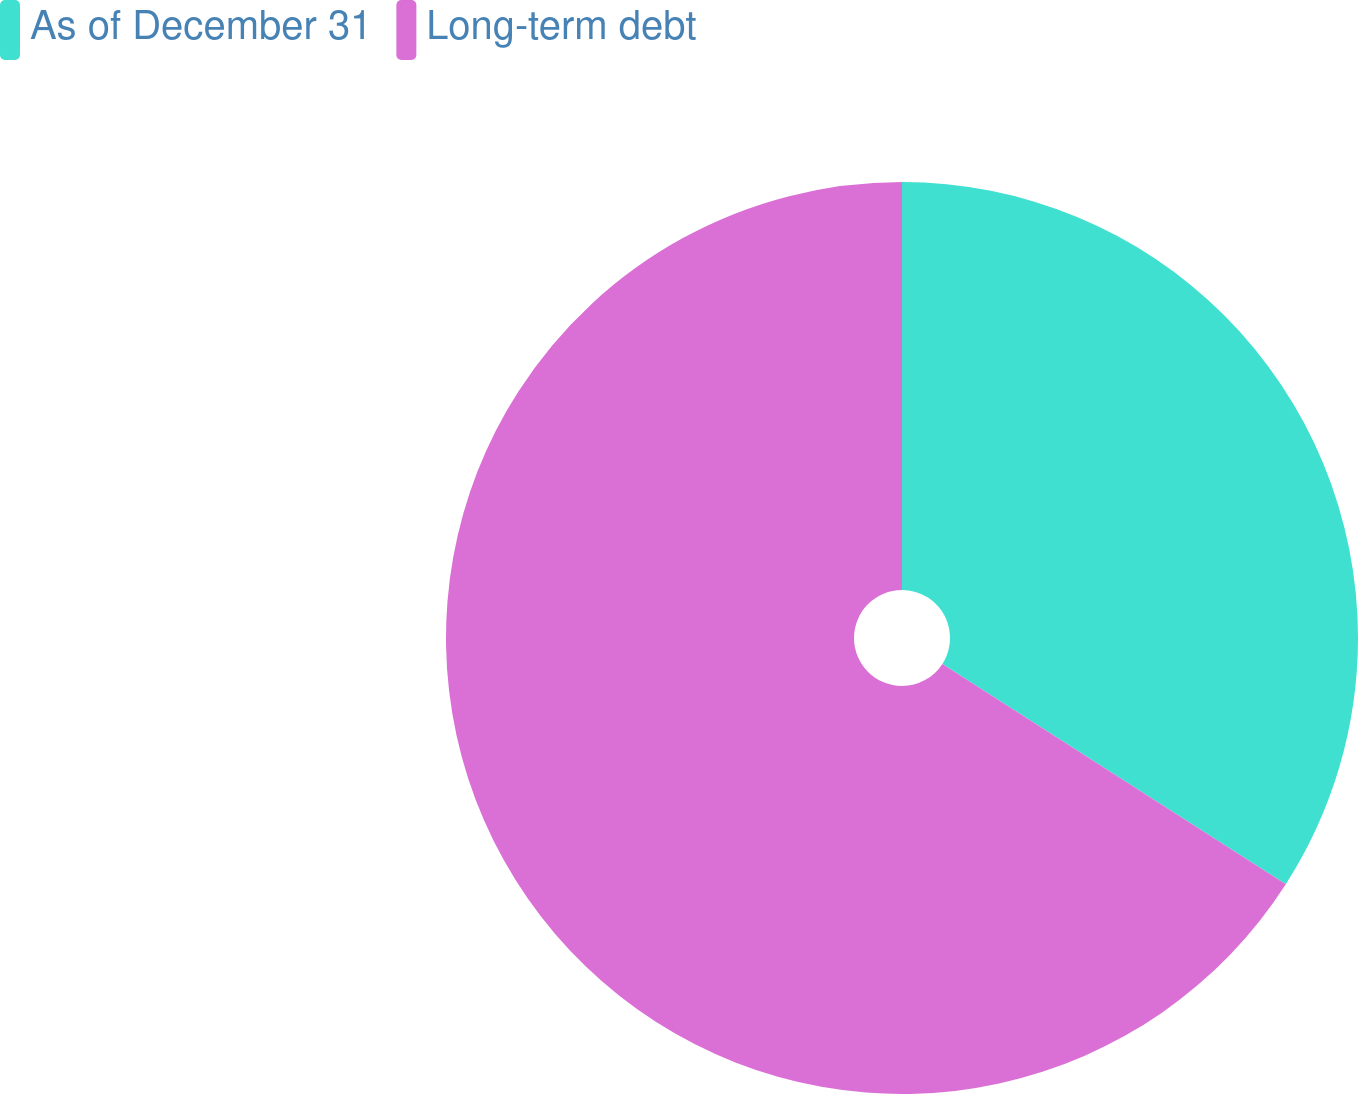<chart> <loc_0><loc_0><loc_500><loc_500><pie_chart><fcel>As of December 31<fcel>Long-term debt<nl><fcel>34.08%<fcel>65.92%<nl></chart> 